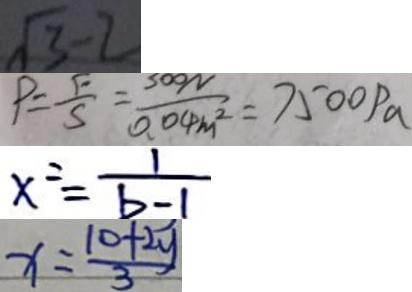Convert formula to latex. <formula><loc_0><loc_0><loc_500><loc_500>\sqrt { 3 } - 2 
 P = \frac { F } { S } = \frac { 3 0 0 N } { 0 . 0 4 m ^ { 2 } } = 7 5 0 0 P a 
 x ^ { 2 } = \frac { 1 } { b - 1 } 
 x = \frac { 1 0 + 2 y } { 3 }</formula> 